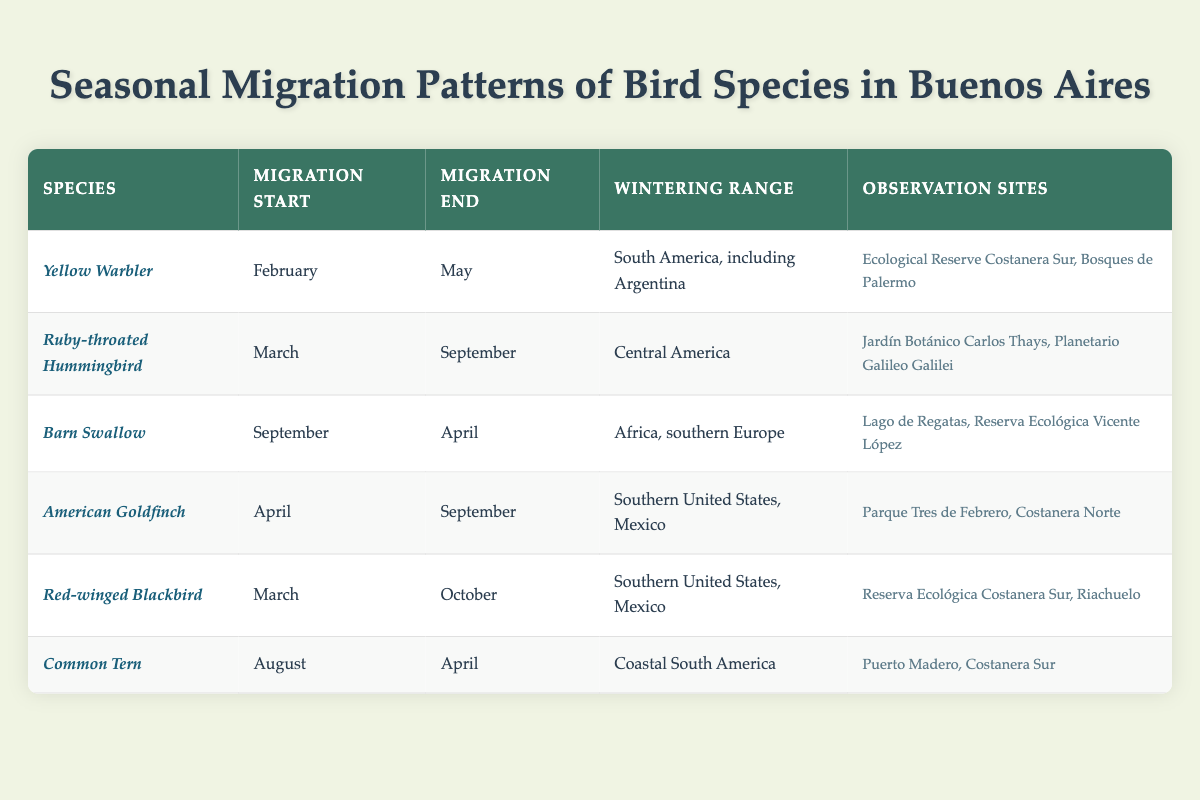What is the migration start month for the Yellow Warbler? According to the table, the Yellow Warbler has a migration start month listed as February.
Answer: February Which bird species migrates during the months of March to October? The table identifies the Red-winged Blackbird as migrating from March to October.
Answer: Red-winged Blackbird How many observation sites are listed for the Ruby-throated Hummingbird? The table states that the Ruby-throated Hummingbird can be observed at two locations: Jardín Botánico Carlos Thays and Planetario Galileo Galilei.
Answer: 2 What is the wintering range of the Barn Swallow? The table indicates that the Barn Swallow's wintering range is Africa and southern Europe.
Answer: Africa, southern Europe Which species has the latest migration end date? The table shows that the Red-winged Blackbird has the latest migration end date in October, compared to other species.
Answer: Red-winged Blackbird List the species that migrate in April. The table lists two species migrating in April: American Goldfinch and Red-winged Blackbird.
Answer: American Goldfinch, Red-winged Blackbird Is it true that the Common Tern's migration starts in August? Yes, the table confirms that the Common Tern starts its migration in August.
Answer: Yes How long is the migration period for the Yellow Warbler? The migration period for the Yellow Warbler is from February to May. This totals three months.
Answer: 3 months Which species have observation sites at the Reserva Ecológica Costanera Sur? Both the Yellow Warbler and the Red-winged Blackbird are observed at the Reserva Ecológica Costanera Sur, according to the table.
Answer: Yellow Warbler, Red-winged Blackbird If you combine the migration periods of the Yellow Warbler and the American Goldfinch, which species has the longer migration duration? The Yellow Warbler migrates for three months (February to May) and the American Goldfinch for five months (April to September). The American Goldfinch has the longer migration duration.
Answer: American Goldfinch 